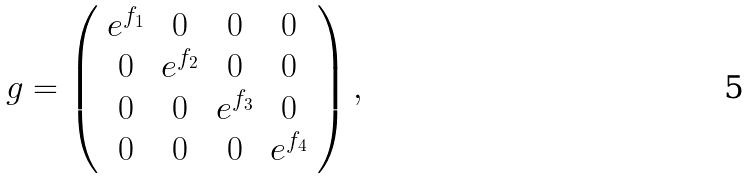<formula> <loc_0><loc_0><loc_500><loc_500>g = \left ( \begin{array} { c c c c } e ^ { f _ { 1 } } & 0 & 0 & 0 \\ 0 & e ^ { f _ { 2 } } & 0 & 0 \\ 0 & 0 & e ^ { f _ { 3 } } & 0 \\ 0 & 0 & 0 & e ^ { f _ { 4 } } \end{array} \right ) ,</formula> 